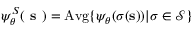<formula> <loc_0><loc_0><loc_500><loc_500>\psi _ { \boldsymbol \theta } ^ { S } ( s ) = A v g \{ \psi _ { \boldsymbol \theta } ( \sigma ( s ) ) | \sigma \in \mathcal { S } \}</formula> 